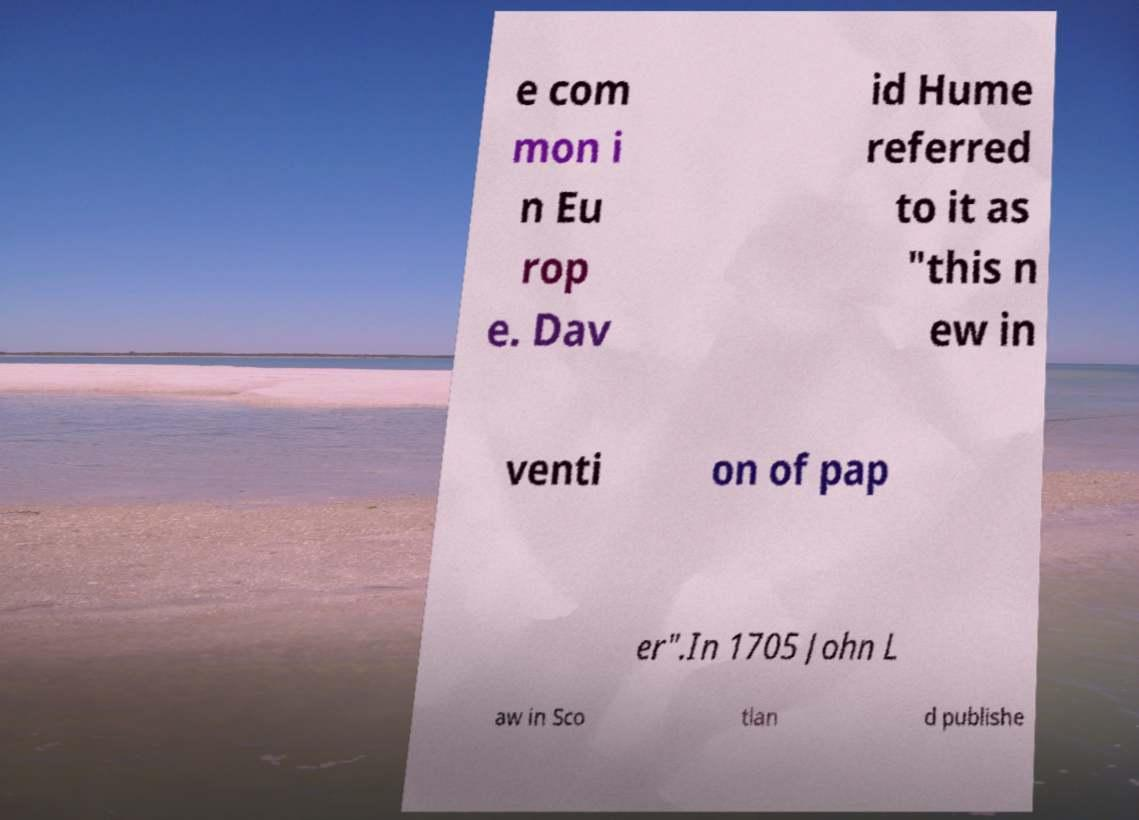Could you assist in decoding the text presented in this image and type it out clearly? e com mon i n Eu rop e. Dav id Hume referred to it as "this n ew in venti on of pap er".In 1705 John L aw in Sco tlan d publishe 